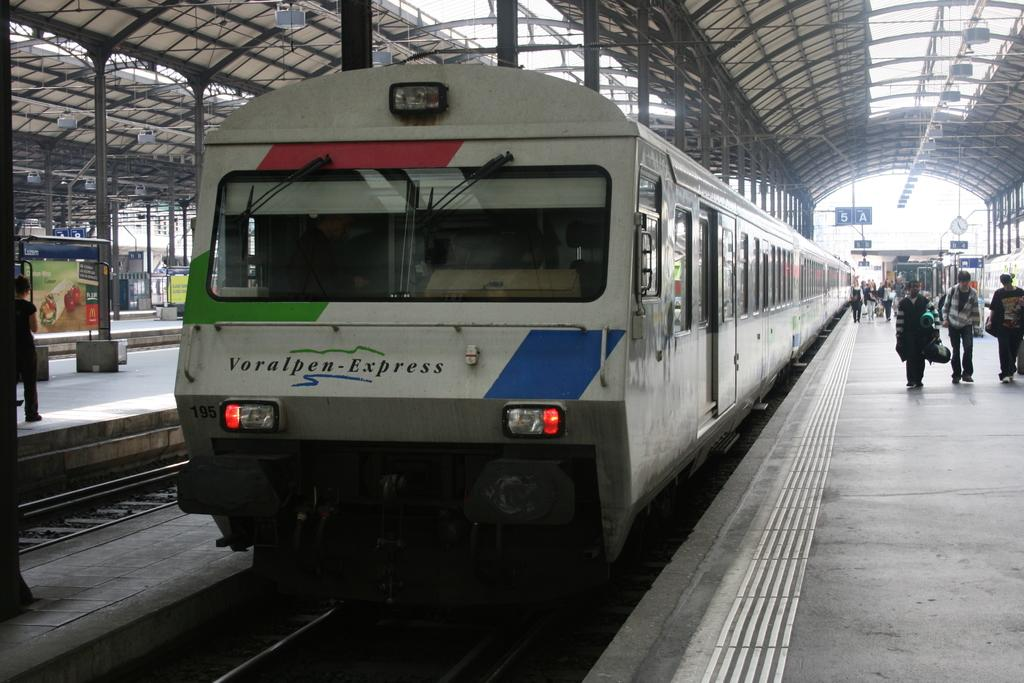<image>
Give a short and clear explanation of the subsequent image. A Voralpen-Express train pulls into a station for passengers. 